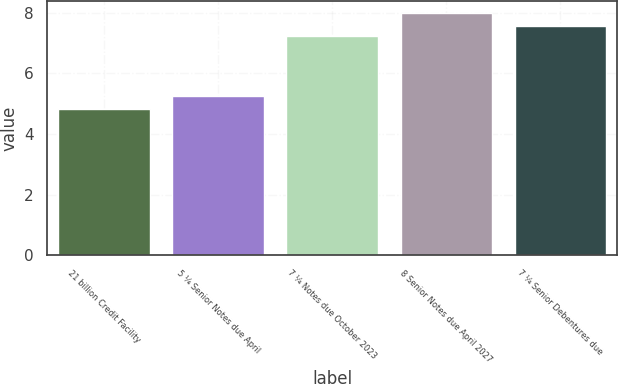Convert chart to OTSL. <chart><loc_0><loc_0><loc_500><loc_500><bar_chart><fcel>21 billion Credit Facility<fcel>5 ¼ Senior Notes due April<fcel>7 ¼ Notes due October 2023<fcel>8 Senior Notes due April 2027<fcel>7 ¼ Senior Debentures due<nl><fcel>4.82<fcel>5.25<fcel>7.25<fcel>8<fcel>7.57<nl></chart> 